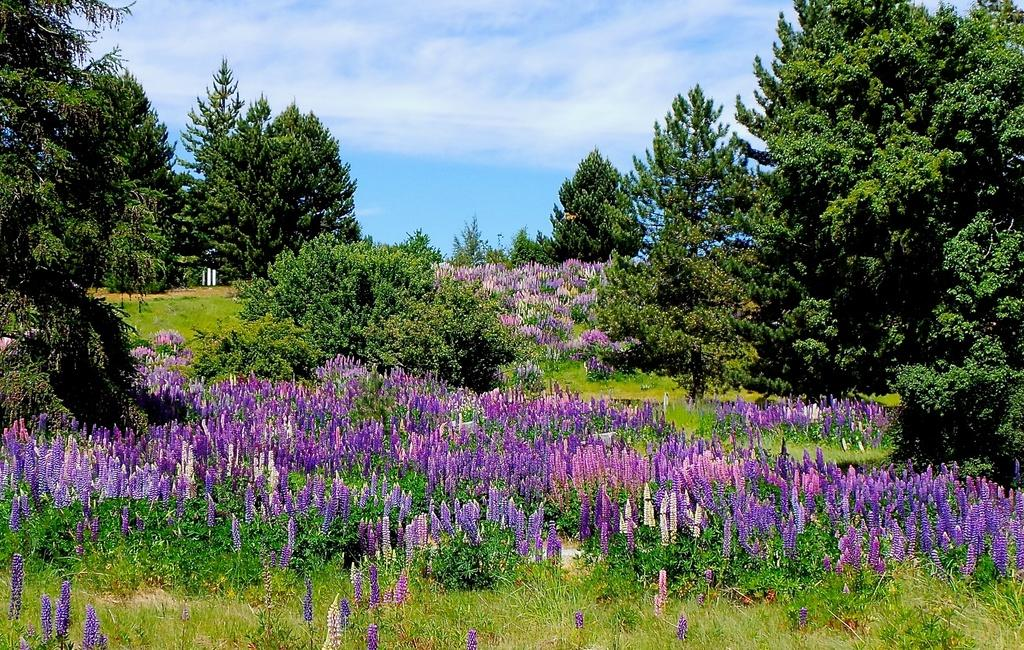What types of vegetation can be seen in the foreground of the image? There are flowers, plants, and trees in the foreground of the image. What is visible at the top of the image? The sky is visible at the top of the image. What can be observed in the sky? Clouds are present in the sky. How many properties are visible in the image? There is no property present in the image; it features vegetation and a sky with clouds. Can you tell me how many sisters are depicted in the image? There are no people, let alone sisters, depicted in the image. 